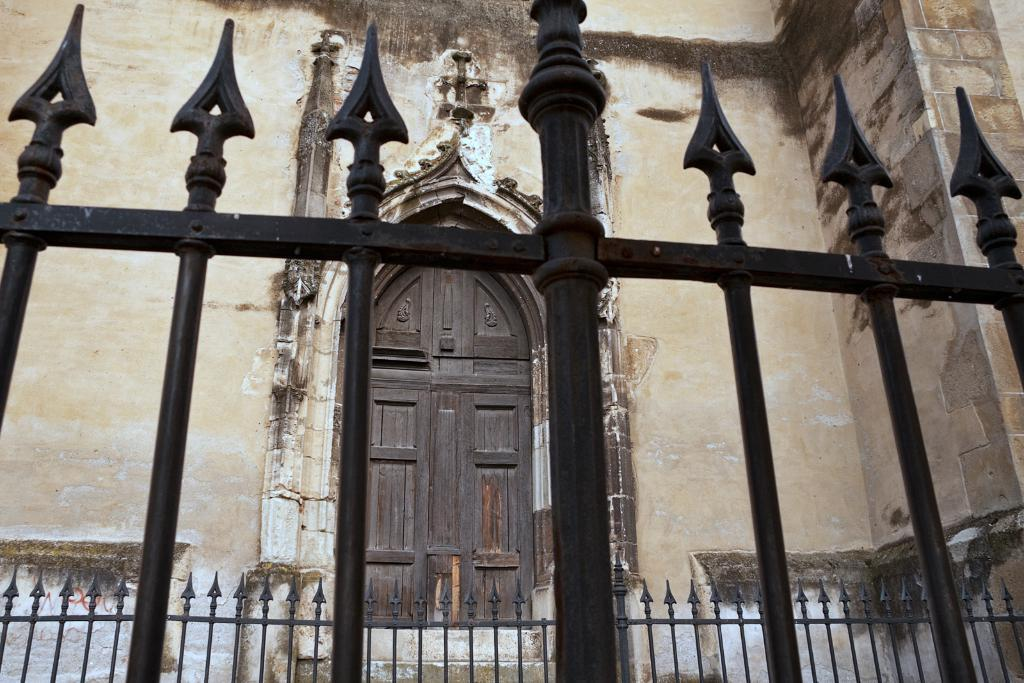What type of barrier is located at the front of the image? There is metal fencing at the front of the image. What structure can be seen at the back side of the image? There is a building at the back side of the image. Where is the door located in the image? The door is at the center of the image. What type of dinosaurs can be seen roaming around the building in the image? There are no dinosaurs present in the image; it features metal fencing, a building, and a door. What type of thunder can be heard in the image? There is no sound present in the image, so it is not possible to determine if thunder can be heard. 